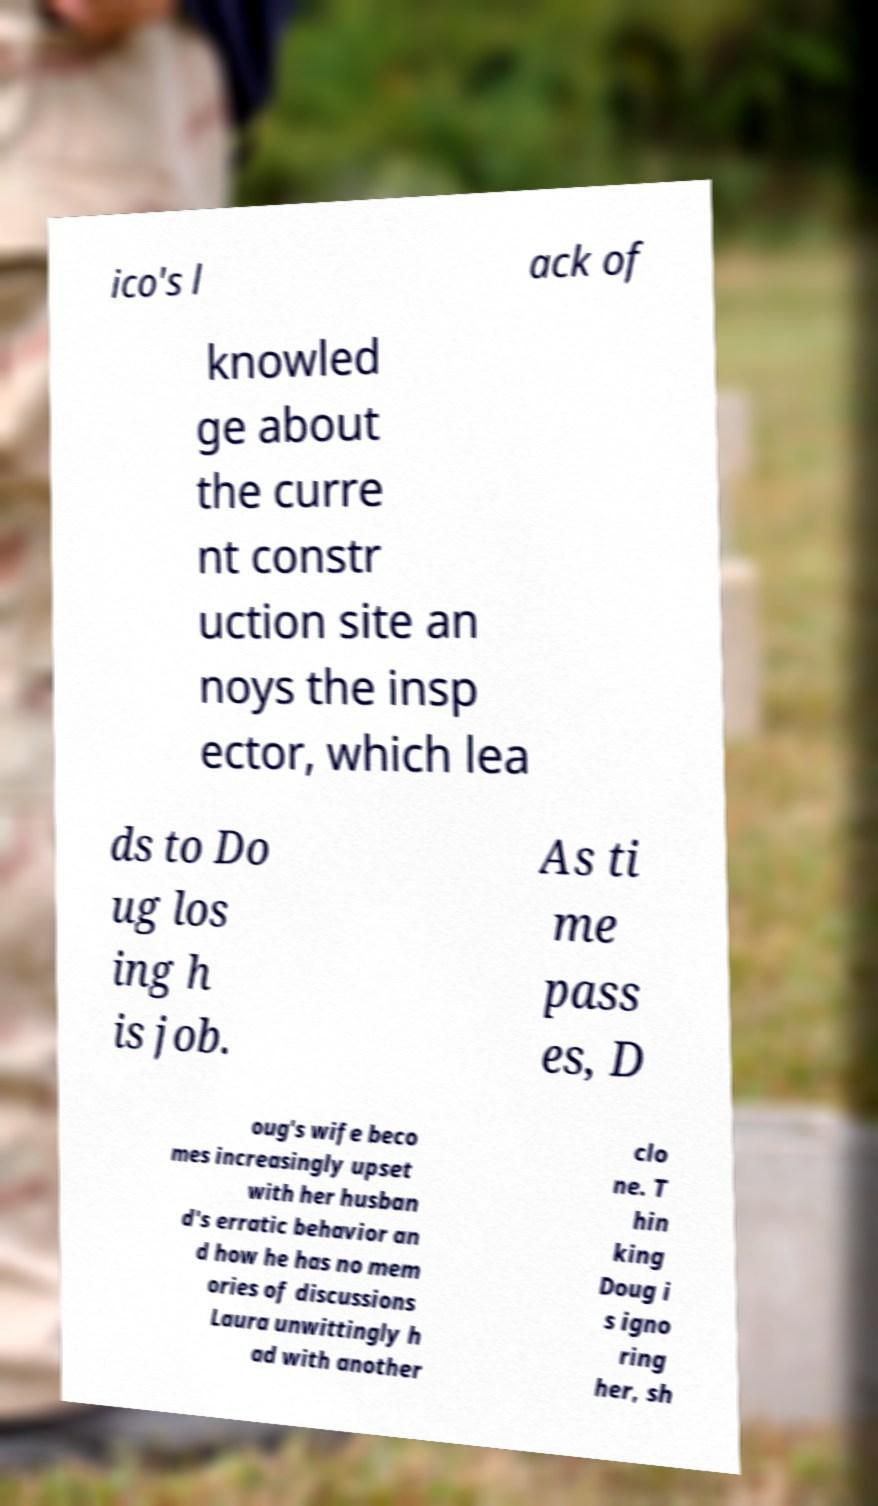What messages or text are displayed in this image? I need them in a readable, typed format. ico's l ack of knowled ge about the curre nt constr uction site an noys the insp ector, which lea ds to Do ug los ing h is job. As ti me pass es, D oug's wife beco mes increasingly upset with her husban d's erratic behavior an d how he has no mem ories of discussions Laura unwittingly h ad with another clo ne. T hin king Doug i s igno ring her, sh 